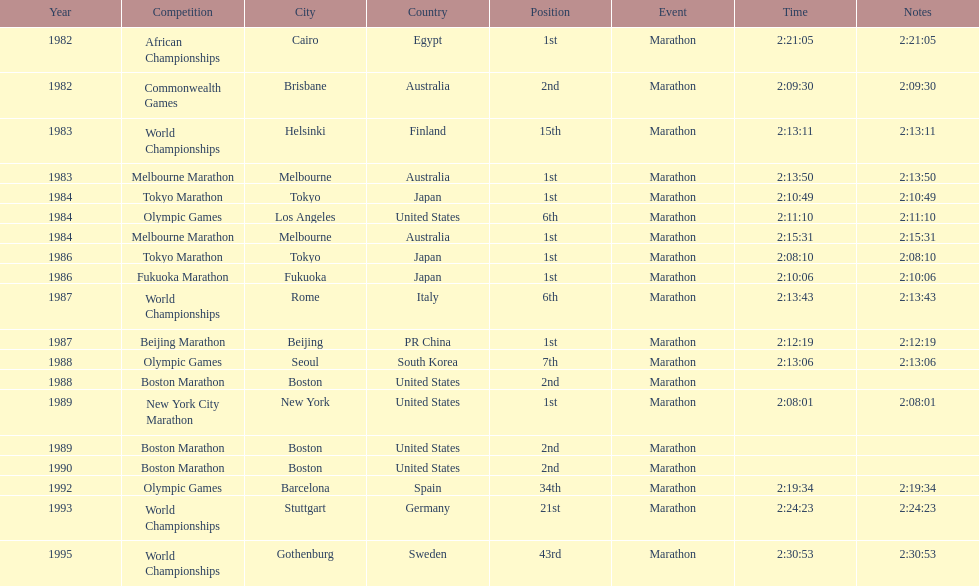Which competition is listed the most in this chart? World Championships. 